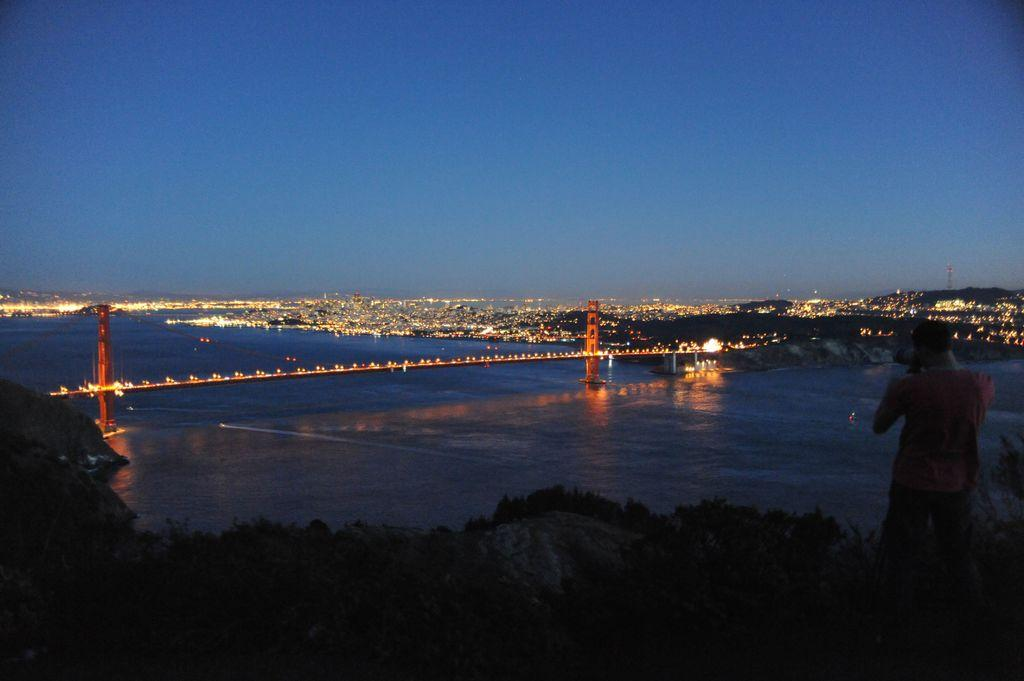What is the person in the image doing? The person is standing on a hill in the image. What can be seen in the background of the image? There is a bridge, lights, water, and the sky visible in the background. Can you describe the bridge in the background? The bridge is located in the background of the image. What is the condition of the sky in the image? The sky is visible at the top of the image. What type of honey is being collected by the person in the image? There is no honey or honey collection activity present in the image. Is there a birthday celebration happening in the image? There is no indication of a birthday celebration in the image. 